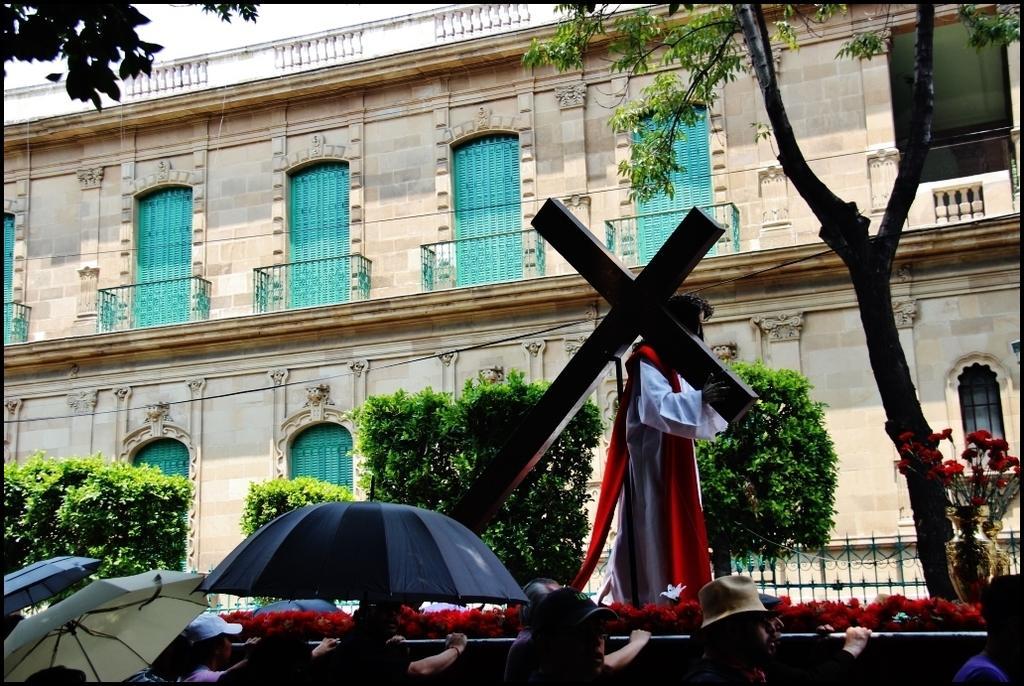In one or two sentences, can you explain what this image depicts? In this image, we can see a person holding a cross and in the background, there is a building and we can see railings, trees, flower vases, some plants and we can see people, some are holding umbrellas and there are some of the people are wearing caps. 